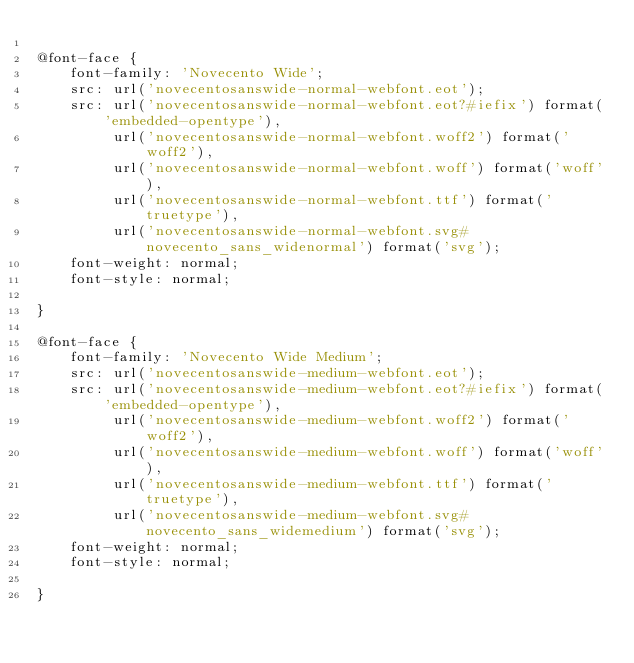<code> <loc_0><loc_0><loc_500><loc_500><_CSS_>
@font-face {
    font-family: 'Novecento Wide';
    src: url('novecentosanswide-normal-webfont.eot');
    src: url('novecentosanswide-normal-webfont.eot?#iefix') format('embedded-opentype'),
         url('novecentosanswide-normal-webfont.woff2') format('woff2'),
         url('novecentosanswide-normal-webfont.woff') format('woff'),
         url('novecentosanswide-normal-webfont.ttf') format('truetype'),
         url('novecentosanswide-normal-webfont.svg#novecento_sans_widenormal') format('svg');
    font-weight: normal;
    font-style: normal;

}

@font-face {
    font-family: 'Novecento Wide Medium';
    src: url('novecentosanswide-medium-webfont.eot');
    src: url('novecentosanswide-medium-webfont.eot?#iefix') format('embedded-opentype'),
         url('novecentosanswide-medium-webfont.woff2') format('woff2'),
         url('novecentosanswide-medium-webfont.woff') format('woff'),
         url('novecentosanswide-medium-webfont.ttf') format('truetype'),
         url('novecentosanswide-medium-webfont.svg#novecento_sans_widemedium') format('svg');
    font-weight: normal;
    font-style: normal;

}</code> 